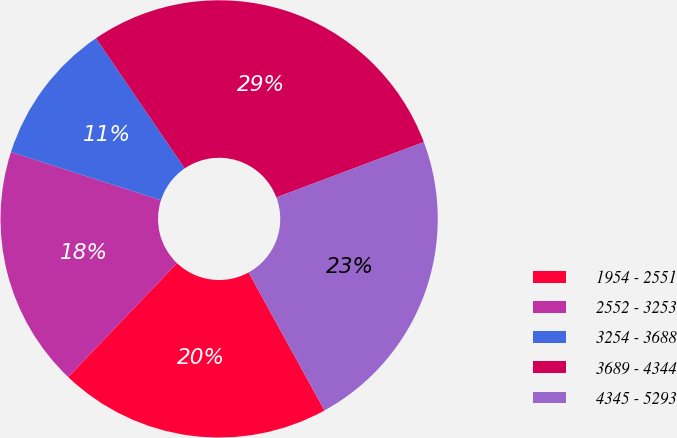Convert chart. <chart><loc_0><loc_0><loc_500><loc_500><pie_chart><fcel>1954 - 2551<fcel>2552 - 3253<fcel>3254 - 3688<fcel>3689 - 4344<fcel>4345 - 5293<nl><fcel>20.13%<fcel>17.82%<fcel>10.53%<fcel>28.81%<fcel>22.71%<nl></chart> 